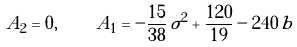<formula> <loc_0><loc_0><loc_500><loc_500>A _ { 2 } = 0 , \, \quad \, A _ { 1 } = - \frac { 1 5 } { 3 8 } \, \sigma ^ { 2 } + \frac { 1 2 0 } { 1 9 } - 2 4 0 \, b</formula> 